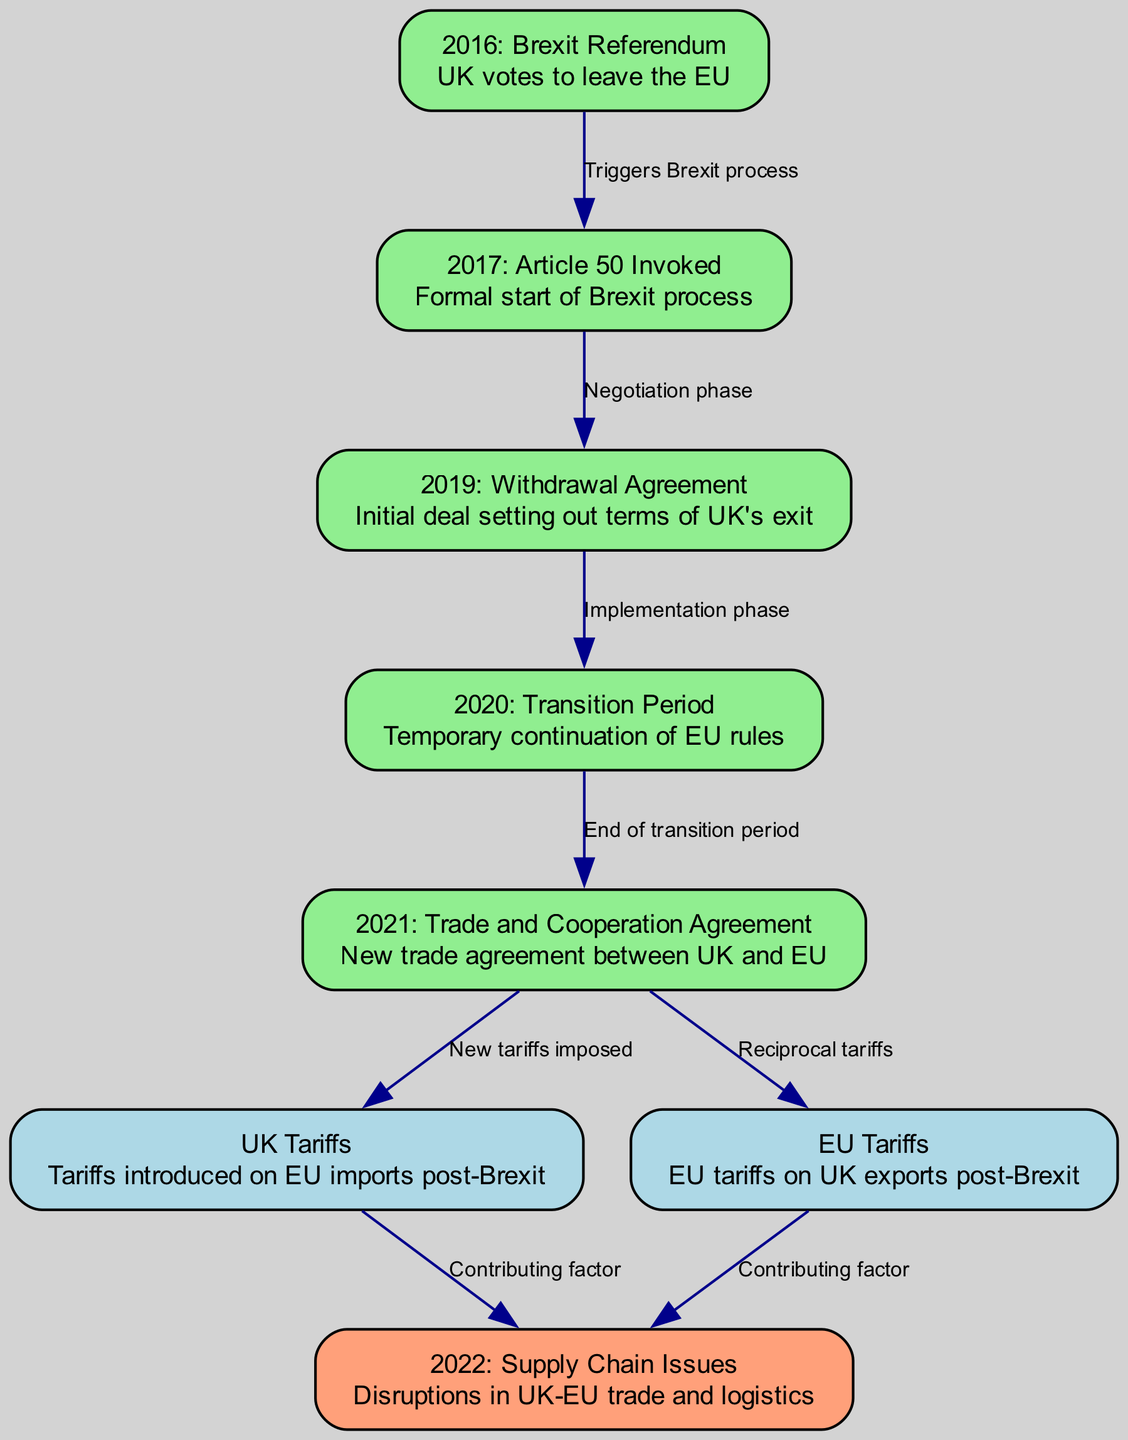What year did the Brexit referendum take place? The diagram indicates that the Brexit referendum occurred in the year 2016. This is identified directly from the node labeled "2016: Brexit Referendum."
Answer: 2016 What is the main event associated with the 2017 node? The node labeled "2017: Article 50 Invoked" describes the formal start of the Brexit process. This relationship connects the Brexit referendum to the invocation of Article 50, indicating a significant action taken after the referendum.
Answer: Formal start of Brexit process How many nodes represent tariff information? Analyzing the nodes, there are two that explicitly mention tariffs: "UK Tariffs" and "EU Tariffs." Therefore, these two nodes indicate the specific tariff information present in the diagram.
Answer: 2 What does the arrow from "2019: Withdrawal Agreement" to "2020: Transition Period" signify? The edge labeled "Implementation phase" indicates the role of the withdrawal agreement in transitioning to the next phase, which is the transition period. This shows a direct connection between the agreement and the subsequent phase in the Brexit timeline.
Answer: Implementation phase What two factors contributed to the 2022 supply chain issues? Looking at the edges leading to "2022: Supply Chain Issues," both "UK Tariffs" and "EU Tariffs" are cited as contributing factors, indicating that tariffs from both sides exacerbated the supply chain disruptions.
Answer: UK Tariffs and EU Tariffs What was established in 2021 regarding trade relations? The node labeled "2021: Trade and Cooperation Agreement" indicates that a new trade agreement was established between the UK and the EU. This reflects a significant development in trade relations that followed the transition period.
Answer: New trade agreement between UK and EU Which event marks the end of the transition period? The transition period is concluded by the node labeled "2021: Trade and Cooperation Agreement," as indicated by the edge labeled "End of transition period" pointing from the transition node to the trade agreement node.
Answer: Trade and Cooperation Agreement What was introduced post-Brexit according to the diagram? The diagram specifically notes "Tariffs introduced on EU imports post-Brexit" under the "UK Tariffs" node, highlighting that the UK imposed tariffs on imports from the EU after leaving the union.
Answer: Tariffs introduced on EU imports post-Brexit What does the diagram indicate about the timeline from the Brexit referendum to the trade cooperation agreement? The diagram’s flow from "2016: Brexit Referendum" through to "2021: Trade and Cooperation Agreement" outlines a sequence of key events, including the invocation of Article 50, withdrawal agreement, transition period, and ultimately establishing the trade and cooperation agreement, showcasing the chronological impact of Brexit on trade relations.
Answer: Sequence of key events 